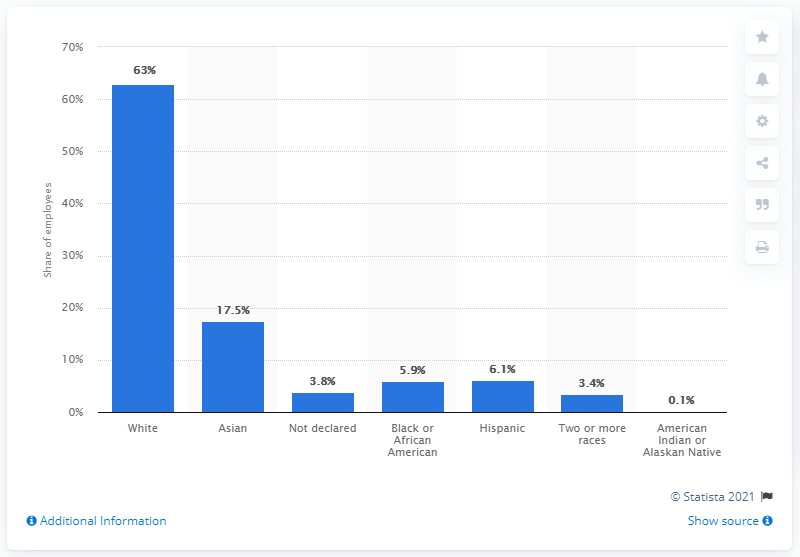Indicate a few pertinent items in this graphic. According to the given information, 17.5% of Etsy employees belong to the Asian ethnicity. 